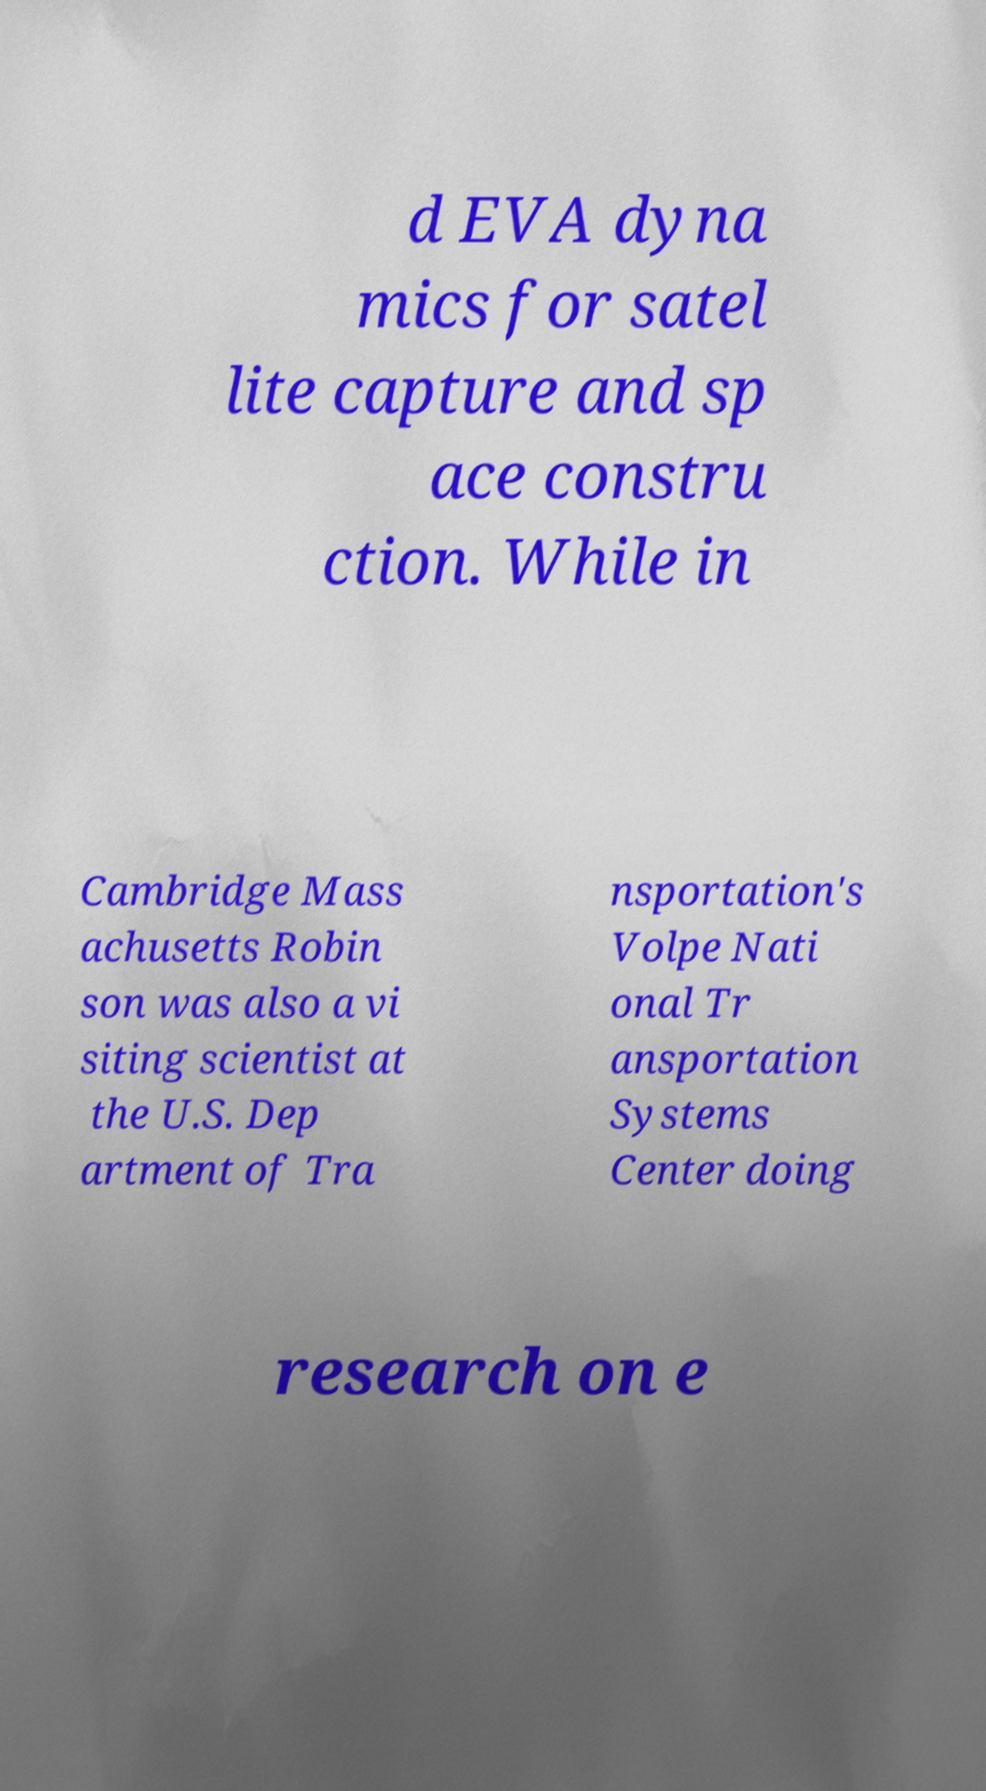Can you accurately transcribe the text from the provided image for me? d EVA dyna mics for satel lite capture and sp ace constru ction. While in Cambridge Mass achusetts Robin son was also a vi siting scientist at the U.S. Dep artment of Tra nsportation's Volpe Nati onal Tr ansportation Systems Center doing research on e 